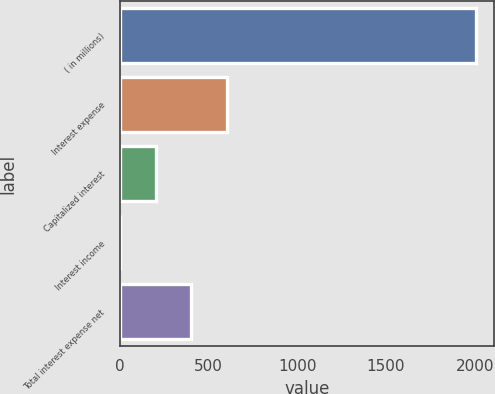Convert chart. <chart><loc_0><loc_0><loc_500><loc_500><bar_chart><fcel>( in millions)<fcel>Interest expense<fcel>Capitalized interest<fcel>Interest income<fcel>Total interest expense net<nl><fcel>2009<fcel>603.26<fcel>201.62<fcel>0.8<fcel>402.44<nl></chart> 